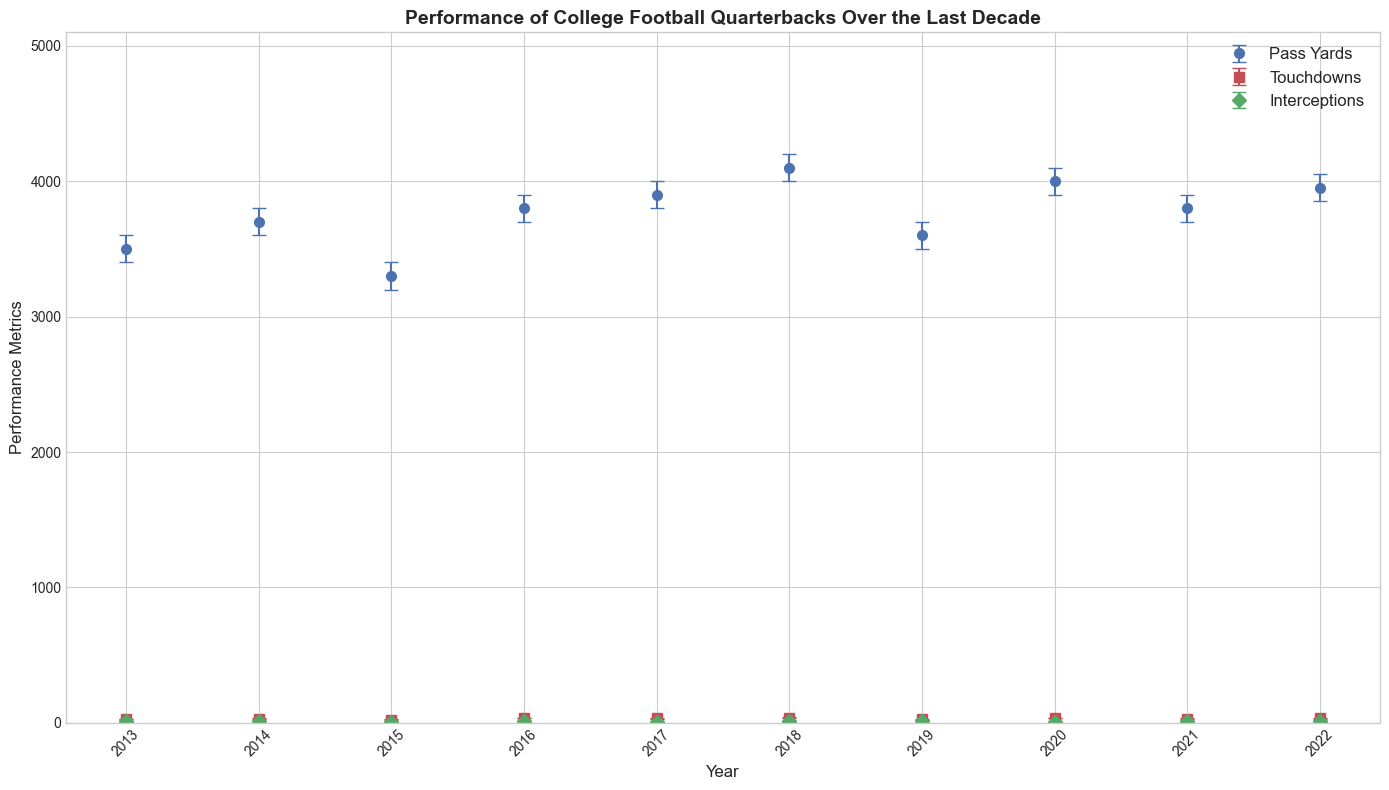Which year had the highest number of pass yards? From the plot, the year with the highest blue dot on the y-axis under "Pass Yards" is 2018.
Answer: 2018 Which player had the lowest number of interceptions? The plot shows green diamonds for interceptions, and the lowest green diamond is in 2017 for Dave Young.
Answer: Dave Young How many more touchdowns did Chris White score in 2016 compared to Bob Brown in 2015? Chris White scored 35 touchdowns in 2016, and Bob Brown scored 24 touchdowns in 2015. The difference is 35 - 24 = 11.
Answer: 11 What is the confidence interval for pass yards in 2020? The error bars for pass yards in 2020 range from 3900 to 4100.
Answer: 3900 to 4100 Which year has the smallest confidence interval for touchdowns? The year with the smallest range indicated by the red error bars around touchdowns is 2019, ranging from 24 to 28.
Answer: 2019 What is the average number of interceptions over the entire decade? Sum of interceptions = 10+12+9+11+8+10+13+9+10+11 = 103, number of years = 10, average = 103/10 = 10.3
Answer: 10.3 Which performance metric has the greatest variation in 2018? Comparing the length of error bars in 2018, the blue (pass yards) and green (interceptions) bars are shorter than the red (touchdowns) bar. Thus, touchdowns have the greatest variation.
Answer: Touchdowns Is there any year where the number of interceptions falls outside the confidence interval for pass yards? Looking at 2022, interceptions by Ian Clark (11) fall within the reported pass yards confidence interval (3850 to 4050). No year has interceptions out of pass yards confidence intervals.
Answer: No 